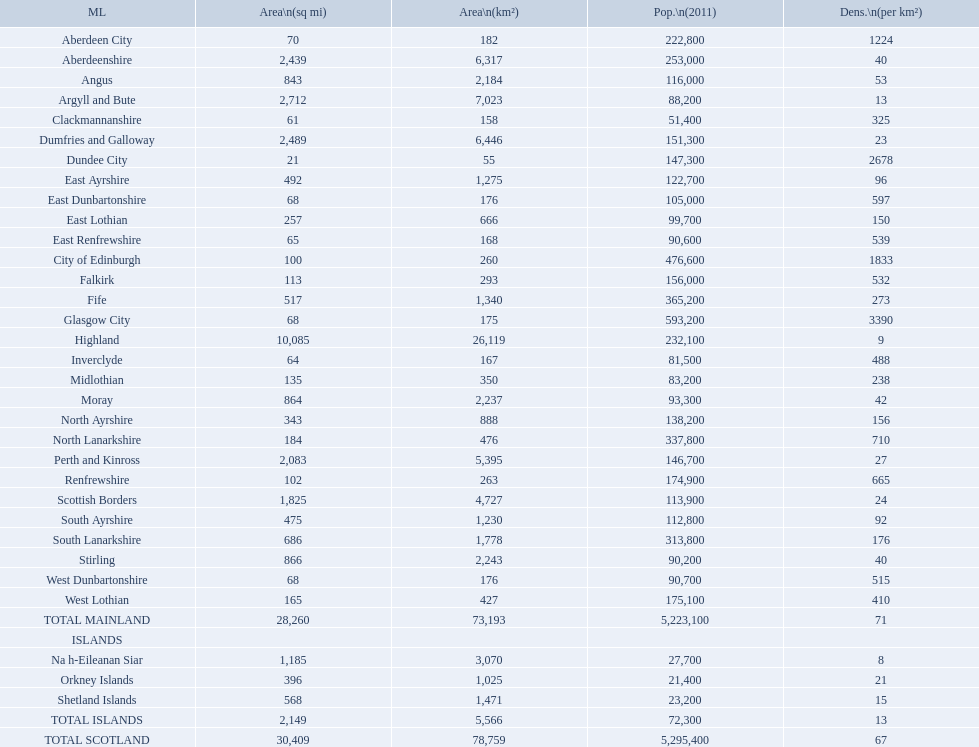What is the average population density in mainland cities? 71. 